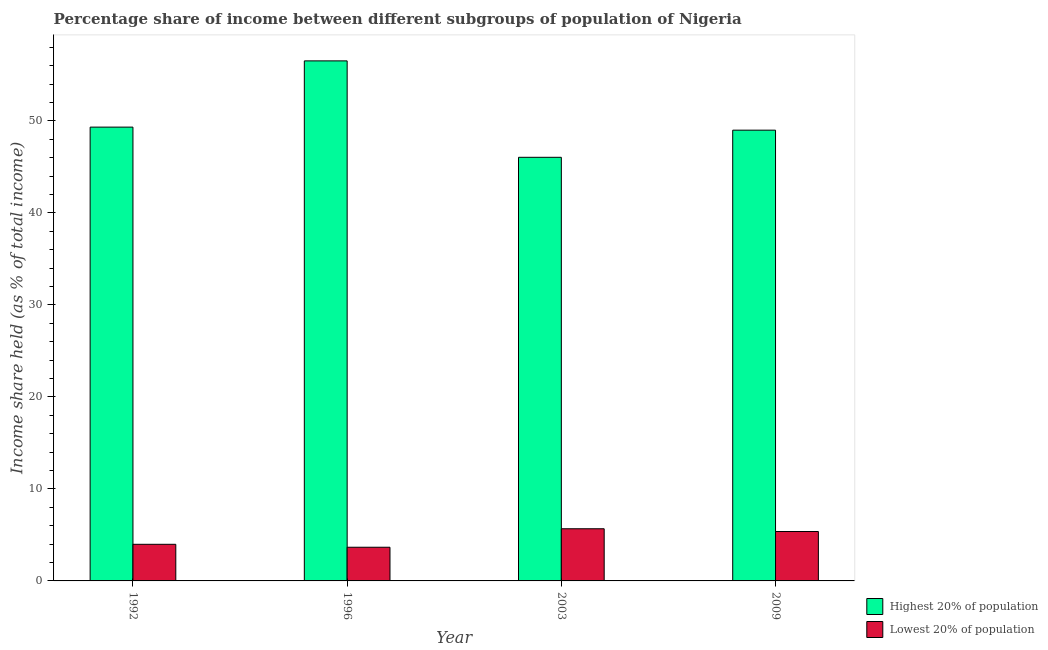Are the number of bars per tick equal to the number of legend labels?
Provide a short and direct response. Yes. How many bars are there on the 3rd tick from the left?
Your response must be concise. 2. How many bars are there on the 3rd tick from the right?
Ensure brevity in your answer.  2. In how many cases, is the number of bars for a given year not equal to the number of legend labels?
Ensure brevity in your answer.  0. What is the income share held by lowest 20% of the population in 1992?
Provide a short and direct response. 3.98. Across all years, what is the maximum income share held by lowest 20% of the population?
Offer a very short reply. 5.67. Across all years, what is the minimum income share held by lowest 20% of the population?
Ensure brevity in your answer.  3.66. In which year was the income share held by lowest 20% of the population maximum?
Your response must be concise. 2003. What is the total income share held by lowest 20% of the population in the graph?
Your answer should be compact. 18.68. What is the difference between the income share held by lowest 20% of the population in 1992 and that in 1996?
Your response must be concise. 0.32. What is the difference between the income share held by highest 20% of the population in 1996 and the income share held by lowest 20% of the population in 2003?
Make the answer very short. 10.48. What is the average income share held by highest 20% of the population per year?
Provide a short and direct response. 50.22. In the year 2003, what is the difference between the income share held by lowest 20% of the population and income share held by highest 20% of the population?
Provide a short and direct response. 0. What is the ratio of the income share held by highest 20% of the population in 2003 to that in 2009?
Provide a succinct answer. 0.94. What is the difference between the highest and the second highest income share held by highest 20% of the population?
Keep it short and to the point. 7.2. What is the difference between the highest and the lowest income share held by highest 20% of the population?
Offer a very short reply. 10.48. In how many years, is the income share held by lowest 20% of the population greater than the average income share held by lowest 20% of the population taken over all years?
Your response must be concise. 2. What does the 1st bar from the left in 1996 represents?
Provide a succinct answer. Highest 20% of population. What does the 2nd bar from the right in 1992 represents?
Provide a succinct answer. Highest 20% of population. How many bars are there?
Ensure brevity in your answer.  8. Are all the bars in the graph horizontal?
Your answer should be very brief. No. How many years are there in the graph?
Provide a succinct answer. 4. What is the difference between two consecutive major ticks on the Y-axis?
Give a very brief answer. 10. Are the values on the major ticks of Y-axis written in scientific E-notation?
Provide a succinct answer. No. Where does the legend appear in the graph?
Your response must be concise. Bottom right. How many legend labels are there?
Offer a terse response. 2. What is the title of the graph?
Provide a succinct answer. Percentage share of income between different subgroups of population of Nigeria. Does "Sanitation services" appear as one of the legend labels in the graph?
Provide a succinct answer. No. What is the label or title of the X-axis?
Offer a very short reply. Year. What is the label or title of the Y-axis?
Make the answer very short. Income share held (as % of total income). What is the Income share held (as % of total income) in Highest 20% of population in 1992?
Your answer should be compact. 49.32. What is the Income share held (as % of total income) in Lowest 20% of population in 1992?
Your response must be concise. 3.98. What is the Income share held (as % of total income) in Highest 20% of population in 1996?
Offer a very short reply. 56.52. What is the Income share held (as % of total income) in Lowest 20% of population in 1996?
Provide a short and direct response. 3.66. What is the Income share held (as % of total income) of Highest 20% of population in 2003?
Make the answer very short. 46.04. What is the Income share held (as % of total income) in Lowest 20% of population in 2003?
Ensure brevity in your answer.  5.67. What is the Income share held (as % of total income) of Highest 20% of population in 2009?
Your response must be concise. 48.99. What is the Income share held (as % of total income) in Lowest 20% of population in 2009?
Your answer should be very brief. 5.37. Across all years, what is the maximum Income share held (as % of total income) of Highest 20% of population?
Make the answer very short. 56.52. Across all years, what is the maximum Income share held (as % of total income) of Lowest 20% of population?
Provide a short and direct response. 5.67. Across all years, what is the minimum Income share held (as % of total income) of Highest 20% of population?
Your answer should be very brief. 46.04. Across all years, what is the minimum Income share held (as % of total income) in Lowest 20% of population?
Make the answer very short. 3.66. What is the total Income share held (as % of total income) of Highest 20% of population in the graph?
Give a very brief answer. 200.87. What is the total Income share held (as % of total income) in Lowest 20% of population in the graph?
Give a very brief answer. 18.68. What is the difference between the Income share held (as % of total income) in Highest 20% of population in 1992 and that in 1996?
Your answer should be compact. -7.2. What is the difference between the Income share held (as % of total income) in Lowest 20% of population in 1992 and that in 1996?
Provide a short and direct response. 0.32. What is the difference between the Income share held (as % of total income) of Highest 20% of population in 1992 and that in 2003?
Provide a short and direct response. 3.28. What is the difference between the Income share held (as % of total income) of Lowest 20% of population in 1992 and that in 2003?
Your answer should be very brief. -1.69. What is the difference between the Income share held (as % of total income) in Highest 20% of population in 1992 and that in 2009?
Offer a terse response. 0.33. What is the difference between the Income share held (as % of total income) in Lowest 20% of population in 1992 and that in 2009?
Offer a terse response. -1.39. What is the difference between the Income share held (as % of total income) in Highest 20% of population in 1996 and that in 2003?
Your answer should be very brief. 10.48. What is the difference between the Income share held (as % of total income) of Lowest 20% of population in 1996 and that in 2003?
Offer a terse response. -2.01. What is the difference between the Income share held (as % of total income) of Highest 20% of population in 1996 and that in 2009?
Give a very brief answer. 7.53. What is the difference between the Income share held (as % of total income) in Lowest 20% of population in 1996 and that in 2009?
Your answer should be very brief. -1.71. What is the difference between the Income share held (as % of total income) in Highest 20% of population in 2003 and that in 2009?
Give a very brief answer. -2.95. What is the difference between the Income share held (as % of total income) in Highest 20% of population in 1992 and the Income share held (as % of total income) in Lowest 20% of population in 1996?
Give a very brief answer. 45.66. What is the difference between the Income share held (as % of total income) of Highest 20% of population in 1992 and the Income share held (as % of total income) of Lowest 20% of population in 2003?
Offer a very short reply. 43.65. What is the difference between the Income share held (as % of total income) of Highest 20% of population in 1992 and the Income share held (as % of total income) of Lowest 20% of population in 2009?
Provide a short and direct response. 43.95. What is the difference between the Income share held (as % of total income) of Highest 20% of population in 1996 and the Income share held (as % of total income) of Lowest 20% of population in 2003?
Keep it short and to the point. 50.85. What is the difference between the Income share held (as % of total income) of Highest 20% of population in 1996 and the Income share held (as % of total income) of Lowest 20% of population in 2009?
Give a very brief answer. 51.15. What is the difference between the Income share held (as % of total income) of Highest 20% of population in 2003 and the Income share held (as % of total income) of Lowest 20% of population in 2009?
Make the answer very short. 40.67. What is the average Income share held (as % of total income) of Highest 20% of population per year?
Provide a succinct answer. 50.22. What is the average Income share held (as % of total income) in Lowest 20% of population per year?
Provide a short and direct response. 4.67. In the year 1992, what is the difference between the Income share held (as % of total income) in Highest 20% of population and Income share held (as % of total income) in Lowest 20% of population?
Keep it short and to the point. 45.34. In the year 1996, what is the difference between the Income share held (as % of total income) in Highest 20% of population and Income share held (as % of total income) in Lowest 20% of population?
Provide a succinct answer. 52.86. In the year 2003, what is the difference between the Income share held (as % of total income) in Highest 20% of population and Income share held (as % of total income) in Lowest 20% of population?
Give a very brief answer. 40.37. In the year 2009, what is the difference between the Income share held (as % of total income) of Highest 20% of population and Income share held (as % of total income) of Lowest 20% of population?
Offer a very short reply. 43.62. What is the ratio of the Income share held (as % of total income) in Highest 20% of population in 1992 to that in 1996?
Your answer should be compact. 0.87. What is the ratio of the Income share held (as % of total income) in Lowest 20% of population in 1992 to that in 1996?
Provide a succinct answer. 1.09. What is the ratio of the Income share held (as % of total income) in Highest 20% of population in 1992 to that in 2003?
Your answer should be very brief. 1.07. What is the ratio of the Income share held (as % of total income) of Lowest 20% of population in 1992 to that in 2003?
Your answer should be compact. 0.7. What is the ratio of the Income share held (as % of total income) in Lowest 20% of population in 1992 to that in 2009?
Give a very brief answer. 0.74. What is the ratio of the Income share held (as % of total income) in Highest 20% of population in 1996 to that in 2003?
Your answer should be compact. 1.23. What is the ratio of the Income share held (as % of total income) of Lowest 20% of population in 1996 to that in 2003?
Provide a short and direct response. 0.65. What is the ratio of the Income share held (as % of total income) in Highest 20% of population in 1996 to that in 2009?
Your response must be concise. 1.15. What is the ratio of the Income share held (as % of total income) in Lowest 20% of population in 1996 to that in 2009?
Offer a very short reply. 0.68. What is the ratio of the Income share held (as % of total income) of Highest 20% of population in 2003 to that in 2009?
Make the answer very short. 0.94. What is the ratio of the Income share held (as % of total income) in Lowest 20% of population in 2003 to that in 2009?
Offer a very short reply. 1.06. What is the difference between the highest and the second highest Income share held (as % of total income) of Lowest 20% of population?
Your response must be concise. 0.3. What is the difference between the highest and the lowest Income share held (as % of total income) in Highest 20% of population?
Your answer should be very brief. 10.48. What is the difference between the highest and the lowest Income share held (as % of total income) in Lowest 20% of population?
Keep it short and to the point. 2.01. 